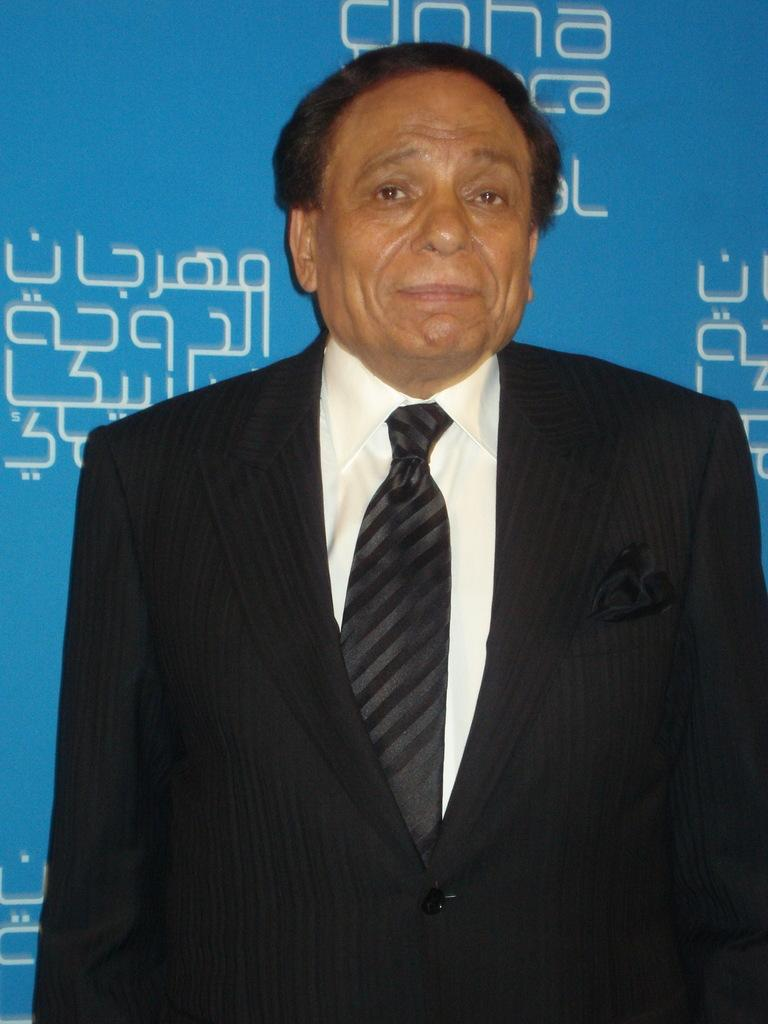Who or what is the main subject in the image? There is a person in the image. Can you describe the position of the person in the image? The person is in front. What can be seen behind the person? There is a banner behind the person. How many passengers are visible in the image? There are no passengers present in the image; it only features a person. What is the person's mind doing in the image? The person's mind is not visible in the image, as it is an abstract concept and not something that can be seen. 